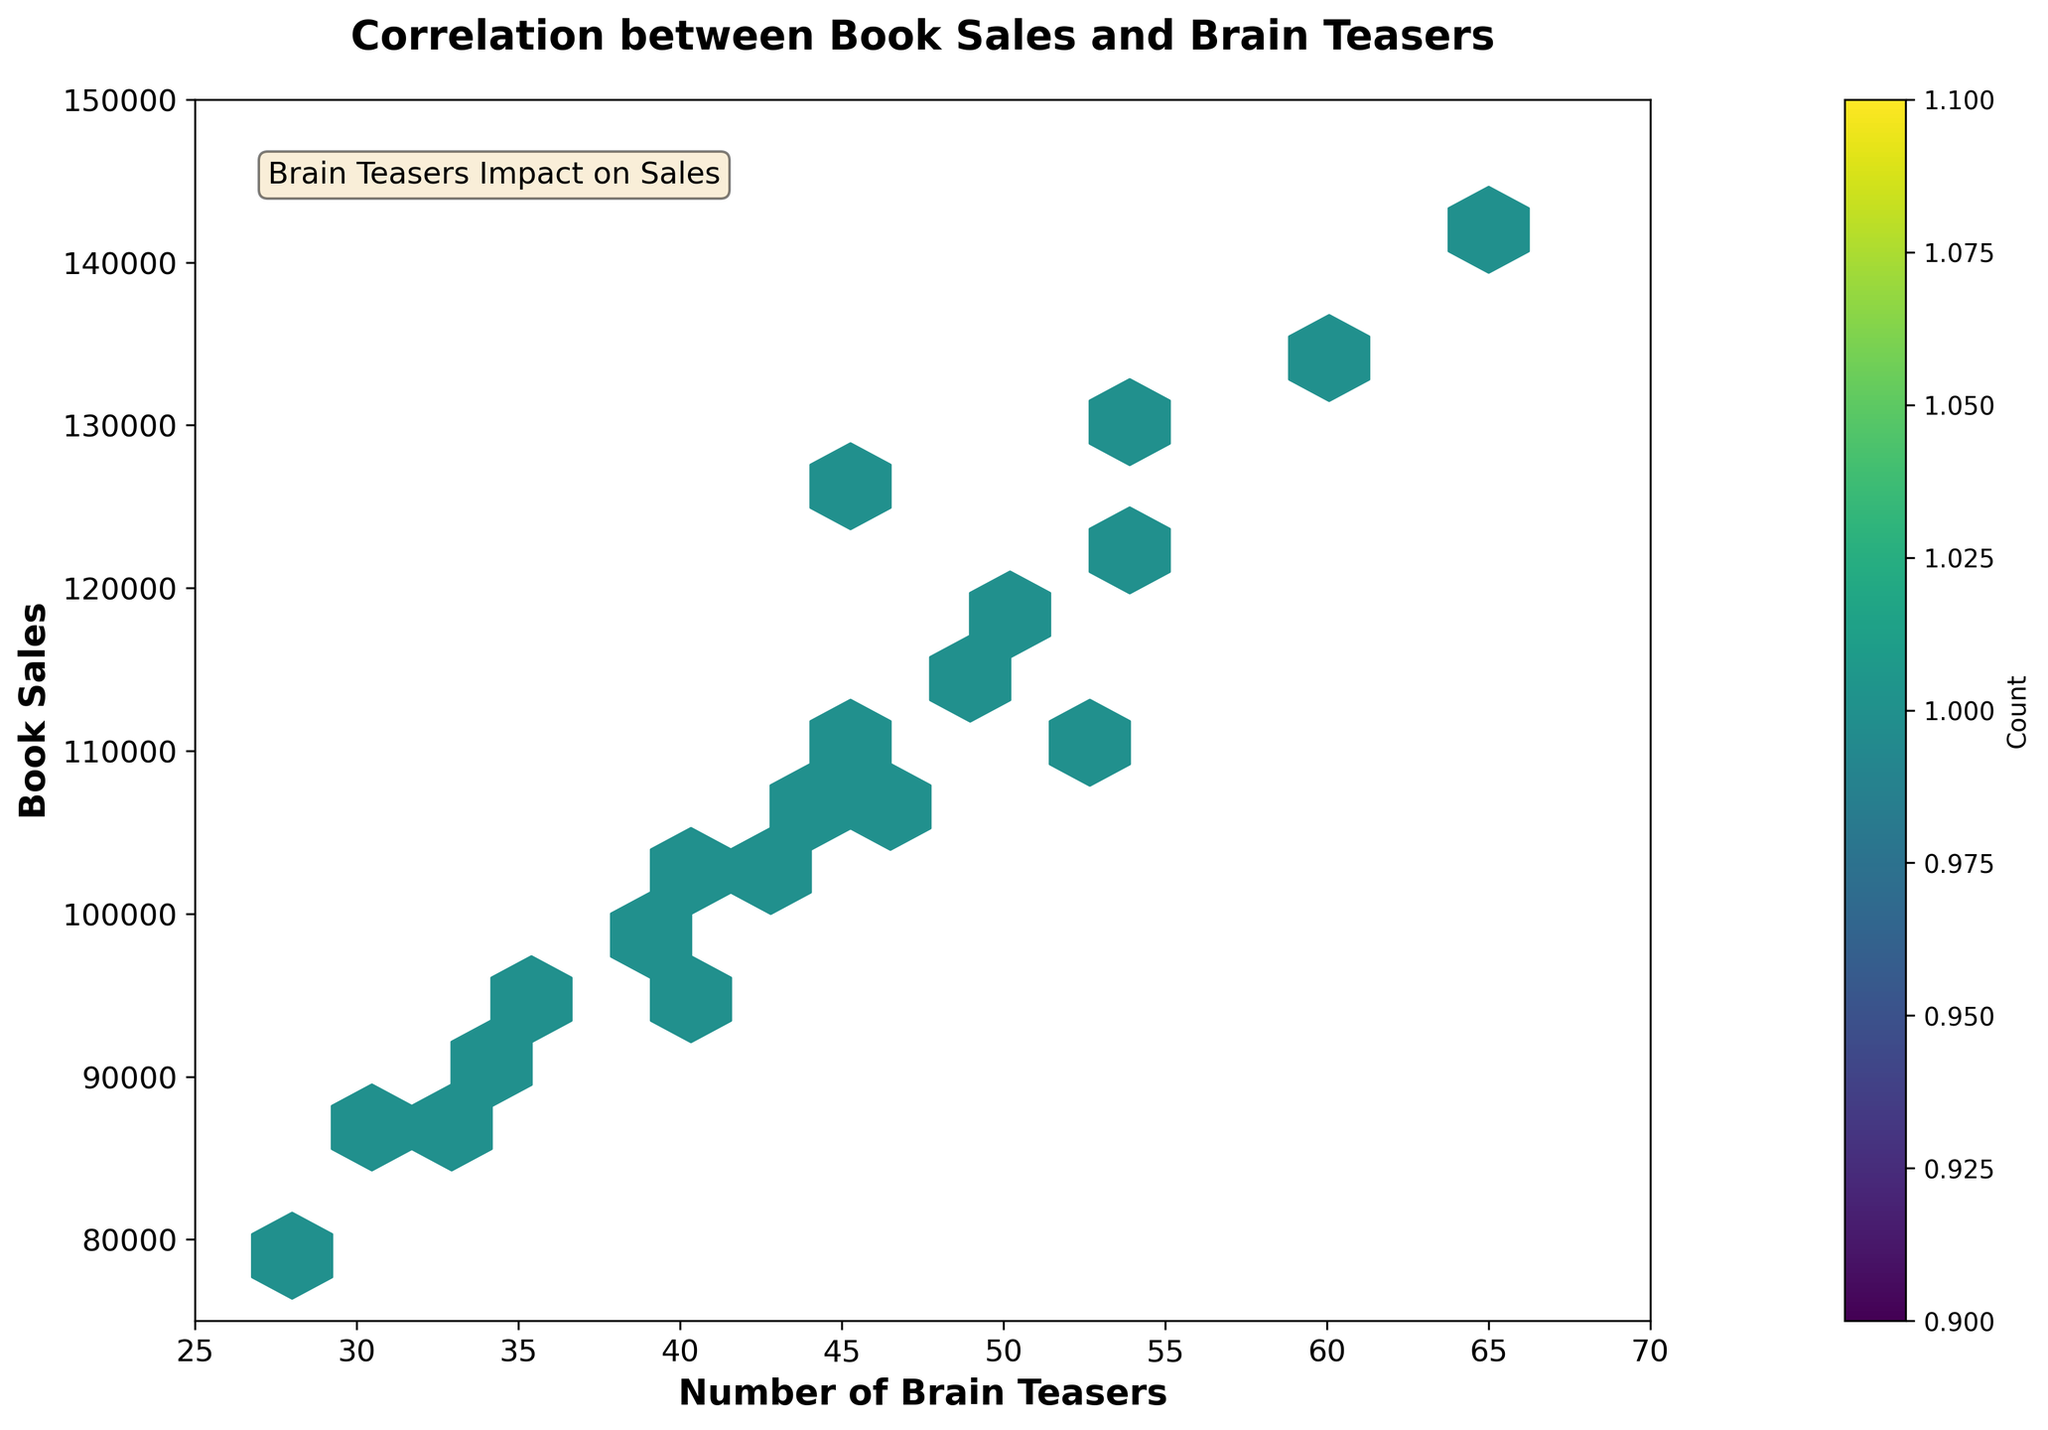What's the title of the plot? The title of the plot is typically found at the top center of the figure. By simply reading the text at the top, the title can be identified as "Correlation between Book Sales and Brain Teasers."
Answer: Correlation between Book Sales and Brain Teasers What are the labels of the X and Y axes? The labels of the axes are usually found next to the respective axes. The label next to the X-axis is 'Number of Brain Teasers', and the label next to the Y-axis is 'Book Sales.'
Answer: Number of Brain Teasers, Book Sales What colors are used to represent data density in the hexbin plot? The color map ('viridis') represents different data densities. Lighter colors indicate lower data density, while darker colors indicate higher data density. By looking at the color bar on the side, one can see the gradient from light to dark green.
Answer: Light to dark green What is the range of the X-axis and Y-axis? The range of the axes is marked by the minimum and maximum values shown along the X and Y axes. The X-axis ranges from 25 to 70, and the Y-axis ranges from 75,000 to 150,000.
Answer: X-axis: 25-70, Y-axis: 75,000-150,000 What's the trend of book sales relative to the number of brain teasers based on the plot? By observing the distribution of hexagons in the plot, one can see that there is an upward trend, indicating that book sales tend to increase as the number of brain teasers increases.
Answer: Book sales generally increase with more brain teasers Are there any noticeable clusters or concentrations in the hexbin plot? By examining the density of the hexagons, one can see where the darker colors (indicating higher data density) are concentrated. There are noticeable clusters around 40-50 brain teasers and 100,000-120,000 sales.
Answer: Yes, around 40-50 brain teasers and 100,000-120,000 sales What does the color bar in the figure represent? The color bar, usually located to the side of the hexbin plot, shows the count of data points within each hexagon. It ranges from lighter to darker shades, indicating lower to higher counts respectively.
Answer: Count of data points How does the inclusion of brain teasers affect book sales based on the data trend shown? By observing the overall trend in the plot, there is a positive relationship, meaning that the number of brain teasers included in a book positively impacts book sales. This is deduced by the upward slope of the dense regions.
Answer: Positive relationship What does the text 'Brain Teasers Impact on Sales' suggest when seen in the plot? The text provides a summarizing interpretation of the plot's main finding. It suggests that brain teasers have a discernible impact on book sales, backing the observed trend in the plot.
Answer: Brain teasers impact book sales 